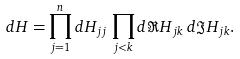<formula> <loc_0><loc_0><loc_500><loc_500>d H = \prod _ { j = 1 } ^ { n } d H _ { j j } \, \prod _ { j < k } d \Re H _ { j k } \, d \Im H _ { j k } .</formula> 